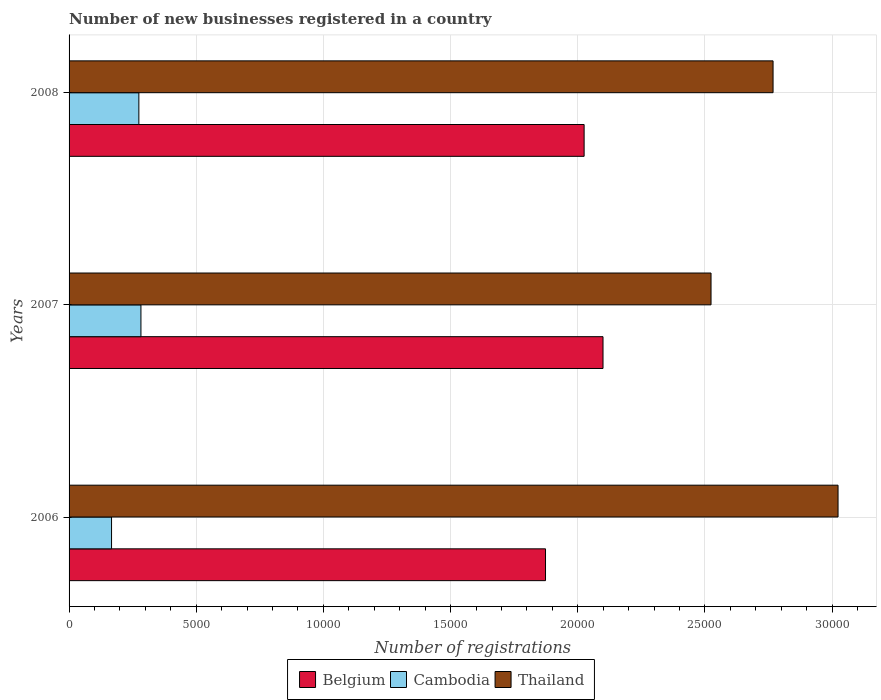How many different coloured bars are there?
Ensure brevity in your answer.  3. Are the number of bars on each tick of the Y-axis equal?
Keep it short and to the point. Yes. How many bars are there on the 3rd tick from the top?
Provide a short and direct response. 3. How many bars are there on the 2nd tick from the bottom?
Make the answer very short. 3. What is the label of the 3rd group of bars from the top?
Your response must be concise. 2006. In how many cases, is the number of bars for a given year not equal to the number of legend labels?
Make the answer very short. 0. What is the number of new businesses registered in Belgium in 2006?
Keep it short and to the point. 1.87e+04. Across all years, what is the maximum number of new businesses registered in Cambodia?
Your answer should be compact. 2826. Across all years, what is the minimum number of new businesses registered in Cambodia?
Your response must be concise. 1670. In which year was the number of new businesses registered in Thailand minimum?
Offer a very short reply. 2007. What is the total number of new businesses registered in Belgium in the graph?
Provide a short and direct response. 6.00e+04. What is the difference between the number of new businesses registered in Thailand in 2006 and that in 2008?
Ensure brevity in your answer.  2555. What is the difference between the number of new businesses registered in Cambodia in 2006 and the number of new businesses registered in Belgium in 2008?
Offer a terse response. -1.86e+04. What is the average number of new businesses registered in Thailand per year?
Your answer should be compact. 2.77e+04. In the year 2007, what is the difference between the number of new businesses registered in Belgium and number of new businesses registered in Thailand?
Your answer should be compact. -4247. In how many years, is the number of new businesses registered in Belgium greater than 10000 ?
Your response must be concise. 3. What is the ratio of the number of new businesses registered in Belgium in 2007 to that in 2008?
Give a very brief answer. 1.04. Is the number of new businesses registered in Cambodia in 2006 less than that in 2007?
Keep it short and to the point. Yes. Is the difference between the number of new businesses registered in Belgium in 2007 and 2008 greater than the difference between the number of new businesses registered in Thailand in 2007 and 2008?
Your answer should be very brief. Yes. What is the difference between the highest and the second highest number of new businesses registered in Belgium?
Your answer should be compact. 743. What is the difference between the highest and the lowest number of new businesses registered in Cambodia?
Offer a terse response. 1156. Is the sum of the number of new businesses registered in Thailand in 2006 and 2008 greater than the maximum number of new businesses registered in Cambodia across all years?
Your response must be concise. Yes. What does the 3rd bar from the top in 2008 represents?
Ensure brevity in your answer.  Belgium. Is it the case that in every year, the sum of the number of new businesses registered in Cambodia and number of new businesses registered in Belgium is greater than the number of new businesses registered in Thailand?
Offer a terse response. No. How many years are there in the graph?
Your answer should be very brief. 3. What is the difference between two consecutive major ticks on the X-axis?
Offer a very short reply. 5000. Does the graph contain any zero values?
Ensure brevity in your answer.  No. Where does the legend appear in the graph?
Provide a short and direct response. Bottom center. What is the title of the graph?
Your response must be concise. Number of new businesses registered in a country. What is the label or title of the X-axis?
Ensure brevity in your answer.  Number of registrations. What is the Number of registrations of Belgium in 2006?
Offer a very short reply. 1.87e+04. What is the Number of registrations of Cambodia in 2006?
Provide a short and direct response. 1670. What is the Number of registrations in Thailand in 2006?
Offer a terse response. 3.02e+04. What is the Number of registrations in Belgium in 2007?
Provide a succinct answer. 2.10e+04. What is the Number of registrations in Cambodia in 2007?
Provide a succinct answer. 2826. What is the Number of registrations in Thailand in 2007?
Make the answer very short. 2.52e+04. What is the Number of registrations in Belgium in 2008?
Ensure brevity in your answer.  2.03e+04. What is the Number of registrations in Cambodia in 2008?
Give a very brief answer. 2744. What is the Number of registrations in Thailand in 2008?
Ensure brevity in your answer.  2.77e+04. Across all years, what is the maximum Number of registrations in Belgium?
Your response must be concise. 2.10e+04. Across all years, what is the maximum Number of registrations in Cambodia?
Make the answer very short. 2826. Across all years, what is the maximum Number of registrations in Thailand?
Your response must be concise. 3.02e+04. Across all years, what is the minimum Number of registrations of Belgium?
Your answer should be very brief. 1.87e+04. Across all years, what is the minimum Number of registrations of Cambodia?
Offer a very short reply. 1670. Across all years, what is the minimum Number of registrations of Thailand?
Your response must be concise. 2.52e+04. What is the total Number of registrations in Belgium in the graph?
Your answer should be compact. 6.00e+04. What is the total Number of registrations of Cambodia in the graph?
Your answer should be compact. 7240. What is the total Number of registrations of Thailand in the graph?
Your response must be concise. 8.32e+04. What is the difference between the Number of registrations of Belgium in 2006 and that in 2007?
Your response must be concise. -2261. What is the difference between the Number of registrations of Cambodia in 2006 and that in 2007?
Give a very brief answer. -1156. What is the difference between the Number of registrations in Thailand in 2006 and that in 2007?
Provide a succinct answer. 4994. What is the difference between the Number of registrations of Belgium in 2006 and that in 2008?
Give a very brief answer. -1518. What is the difference between the Number of registrations in Cambodia in 2006 and that in 2008?
Your answer should be very brief. -1074. What is the difference between the Number of registrations in Thailand in 2006 and that in 2008?
Give a very brief answer. 2555. What is the difference between the Number of registrations of Belgium in 2007 and that in 2008?
Provide a succinct answer. 743. What is the difference between the Number of registrations in Thailand in 2007 and that in 2008?
Your answer should be compact. -2439. What is the difference between the Number of registrations in Belgium in 2006 and the Number of registrations in Cambodia in 2007?
Your response must be concise. 1.59e+04. What is the difference between the Number of registrations in Belgium in 2006 and the Number of registrations in Thailand in 2007?
Ensure brevity in your answer.  -6508. What is the difference between the Number of registrations in Cambodia in 2006 and the Number of registrations in Thailand in 2007?
Your answer should be very brief. -2.36e+04. What is the difference between the Number of registrations in Belgium in 2006 and the Number of registrations in Cambodia in 2008?
Provide a short and direct response. 1.60e+04. What is the difference between the Number of registrations in Belgium in 2006 and the Number of registrations in Thailand in 2008?
Ensure brevity in your answer.  -8947. What is the difference between the Number of registrations in Cambodia in 2006 and the Number of registrations in Thailand in 2008?
Keep it short and to the point. -2.60e+04. What is the difference between the Number of registrations of Belgium in 2007 and the Number of registrations of Cambodia in 2008?
Keep it short and to the point. 1.82e+04. What is the difference between the Number of registrations in Belgium in 2007 and the Number of registrations in Thailand in 2008?
Provide a short and direct response. -6686. What is the difference between the Number of registrations of Cambodia in 2007 and the Number of registrations of Thailand in 2008?
Your answer should be very brief. -2.49e+04. What is the average Number of registrations of Belgium per year?
Offer a terse response. 2.00e+04. What is the average Number of registrations of Cambodia per year?
Ensure brevity in your answer.  2413.33. What is the average Number of registrations in Thailand per year?
Provide a short and direct response. 2.77e+04. In the year 2006, what is the difference between the Number of registrations in Belgium and Number of registrations in Cambodia?
Give a very brief answer. 1.71e+04. In the year 2006, what is the difference between the Number of registrations in Belgium and Number of registrations in Thailand?
Keep it short and to the point. -1.15e+04. In the year 2006, what is the difference between the Number of registrations in Cambodia and Number of registrations in Thailand?
Your answer should be compact. -2.86e+04. In the year 2007, what is the difference between the Number of registrations in Belgium and Number of registrations in Cambodia?
Provide a succinct answer. 1.82e+04. In the year 2007, what is the difference between the Number of registrations in Belgium and Number of registrations in Thailand?
Provide a short and direct response. -4247. In the year 2007, what is the difference between the Number of registrations in Cambodia and Number of registrations in Thailand?
Make the answer very short. -2.24e+04. In the year 2008, what is the difference between the Number of registrations in Belgium and Number of registrations in Cambodia?
Your answer should be very brief. 1.75e+04. In the year 2008, what is the difference between the Number of registrations in Belgium and Number of registrations in Thailand?
Ensure brevity in your answer.  -7429. In the year 2008, what is the difference between the Number of registrations in Cambodia and Number of registrations in Thailand?
Your response must be concise. -2.49e+04. What is the ratio of the Number of registrations of Belgium in 2006 to that in 2007?
Give a very brief answer. 0.89. What is the ratio of the Number of registrations in Cambodia in 2006 to that in 2007?
Give a very brief answer. 0.59. What is the ratio of the Number of registrations of Thailand in 2006 to that in 2007?
Ensure brevity in your answer.  1.2. What is the ratio of the Number of registrations of Belgium in 2006 to that in 2008?
Provide a succinct answer. 0.93. What is the ratio of the Number of registrations in Cambodia in 2006 to that in 2008?
Ensure brevity in your answer.  0.61. What is the ratio of the Number of registrations in Thailand in 2006 to that in 2008?
Provide a short and direct response. 1.09. What is the ratio of the Number of registrations in Belgium in 2007 to that in 2008?
Make the answer very short. 1.04. What is the ratio of the Number of registrations of Cambodia in 2007 to that in 2008?
Offer a very short reply. 1.03. What is the ratio of the Number of registrations in Thailand in 2007 to that in 2008?
Your answer should be very brief. 0.91. What is the difference between the highest and the second highest Number of registrations of Belgium?
Give a very brief answer. 743. What is the difference between the highest and the second highest Number of registrations of Cambodia?
Your answer should be very brief. 82. What is the difference between the highest and the second highest Number of registrations in Thailand?
Give a very brief answer. 2555. What is the difference between the highest and the lowest Number of registrations of Belgium?
Make the answer very short. 2261. What is the difference between the highest and the lowest Number of registrations of Cambodia?
Your response must be concise. 1156. What is the difference between the highest and the lowest Number of registrations in Thailand?
Your response must be concise. 4994. 